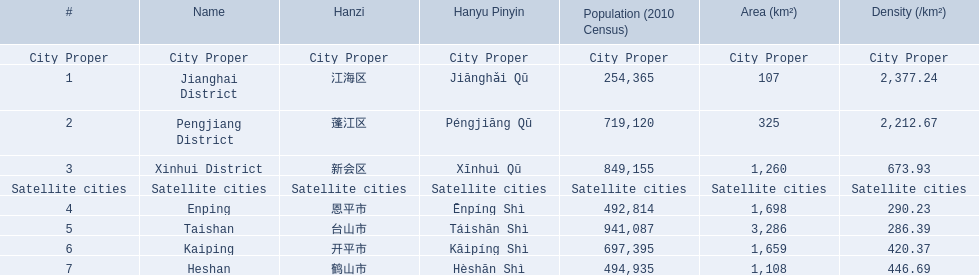What are all of the satellite cities? Enping, Taishan, Kaiping, Heshan. Of these, which has the highest population? Taishan. 